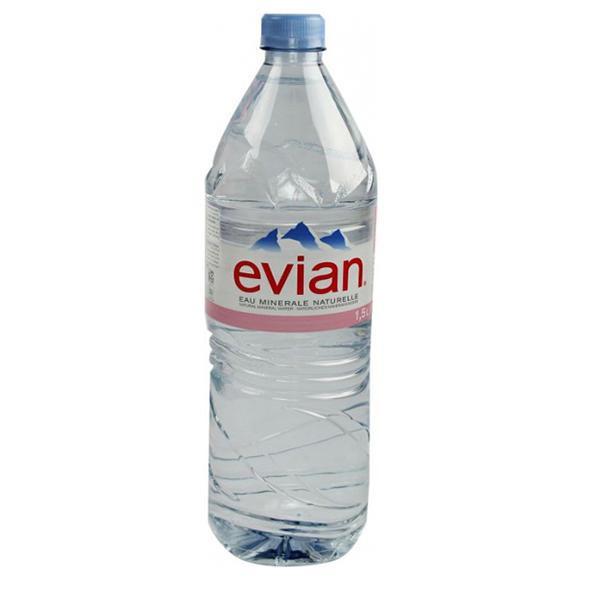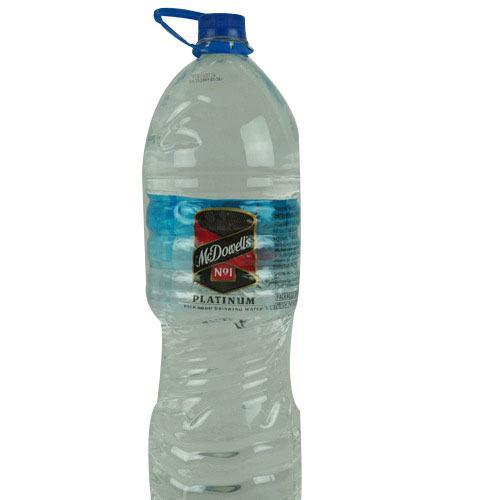The first image is the image on the left, the second image is the image on the right. Given the left and right images, does the statement "There are four water bottles with red labels." hold true? Answer yes or no. No. The first image is the image on the left, the second image is the image on the right. Analyze the images presented: Is the assertion "Two bottles of water are the same shape and coloring, and have white caps, but have different labels." valid? Answer yes or no. No. 